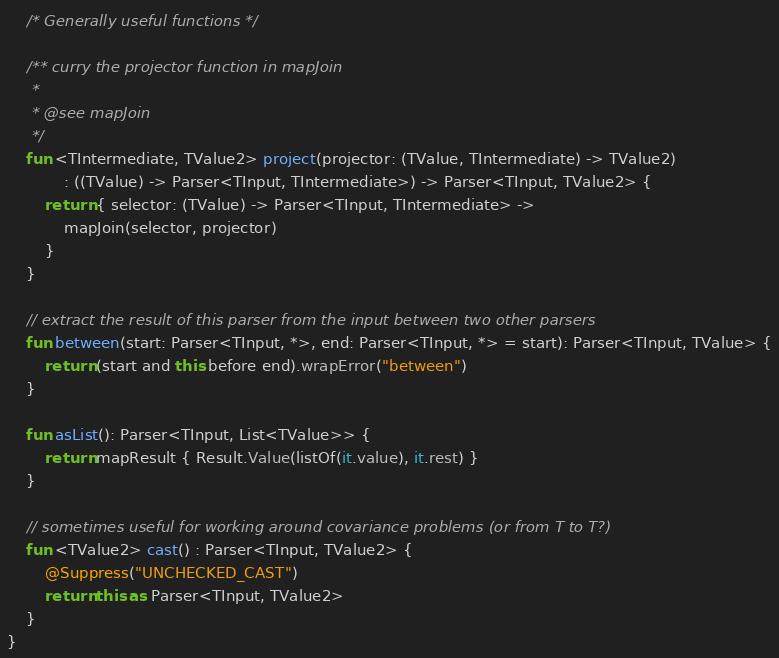<code> <loc_0><loc_0><loc_500><loc_500><_Kotlin_>
    /* Generally useful functions */

    /** curry the projector function in mapJoin
     *
     * @see mapJoin
     */
    fun <TIntermediate, TValue2> project(projector: (TValue, TIntermediate) -> TValue2)
            : ((TValue) -> Parser<TInput, TIntermediate>) -> Parser<TInput, TValue2> {
        return { selector: (TValue) -> Parser<TInput, TIntermediate> ->
            mapJoin(selector, projector)
        }
    }

    // extract the result of this parser from the input between two other parsers
    fun between(start: Parser<TInput, *>, end: Parser<TInput, *> = start): Parser<TInput, TValue> {
        return (start and this before end).wrapError("between")
    }

    fun asList(): Parser<TInput, List<TValue>> {
        return mapResult { Result.Value(listOf(it.value), it.rest) }
    }

    // sometimes useful for working around covariance problems (or from T to T?)
    fun <TValue2> cast() : Parser<TInput, TValue2> {
        @Suppress("UNCHECKED_CAST")
        return this as Parser<TInput, TValue2>
    }
}</code> 